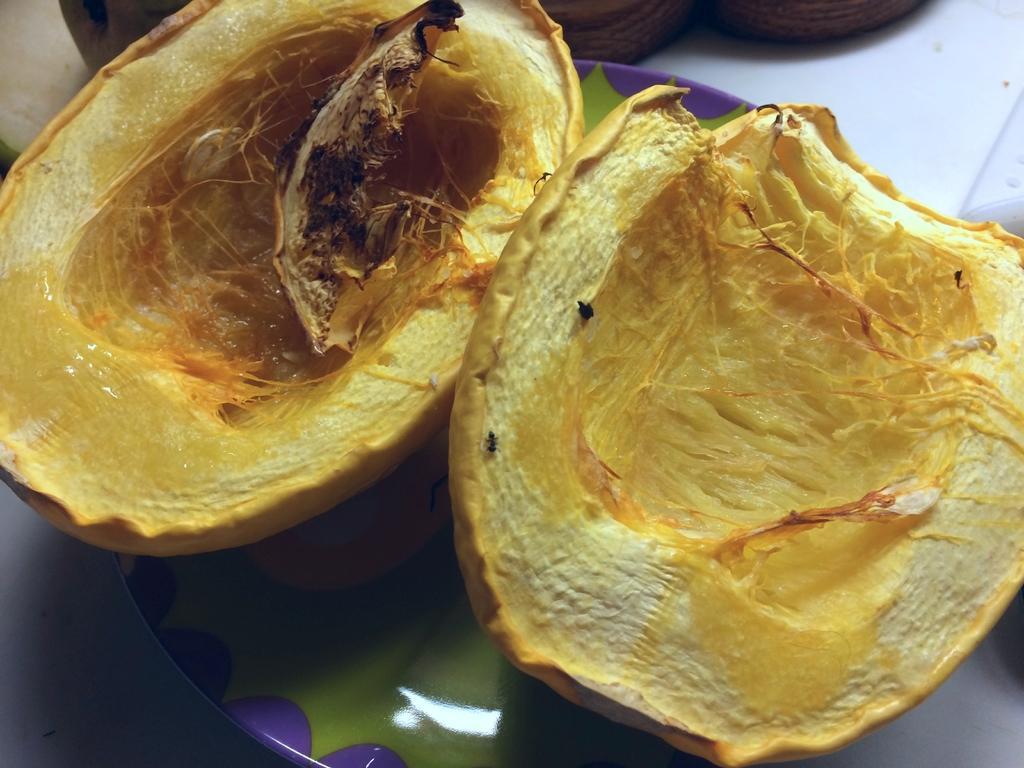Could you give a brief overview of what you see in this image? In this picture we can see fruits in the plate. 